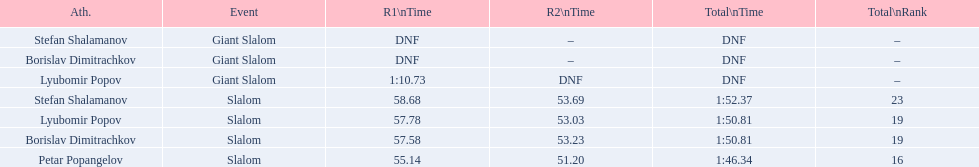What were the event names during bulgaria at the 1988 winter olympics? Stefan Shalamanov, Borislav Dimitrachkov, Lyubomir Popov. And which players participated at giant slalom? Giant Slalom, Giant Slalom, Giant Slalom, Slalom, Slalom, Slalom, Slalom. What were their race 1 times? DNF, DNF, 1:10.73. What was lyubomir popov's personal time? 1:10.73. 